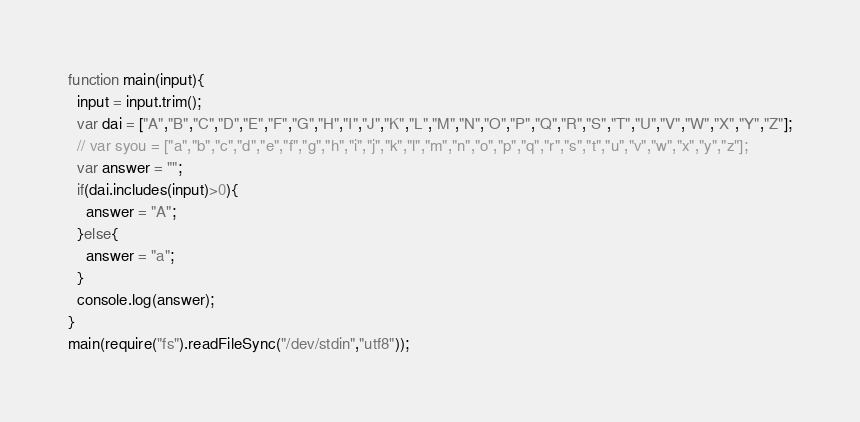<code> <loc_0><loc_0><loc_500><loc_500><_JavaScript_>function main(input){
  input = input.trim();
  var dai = ["A","B","C","D","E","F","G","H","I","J","K","L","M","N","O","P","Q","R","S","T","U","V","W","X","Y","Z"];
  // var syou = ["a","b","c","d","e","f","g","h","i","j","k","l","m","n","o","p","q","r","s","t","u","v","w","x","y","z"];
  var answer = "";
  if(dai.includes(input)>0){
    answer = "A";
  }else{
    answer = "a";
  }
  console.log(answer);
}
main(require("fs").readFileSync("/dev/stdin","utf8"));</code> 